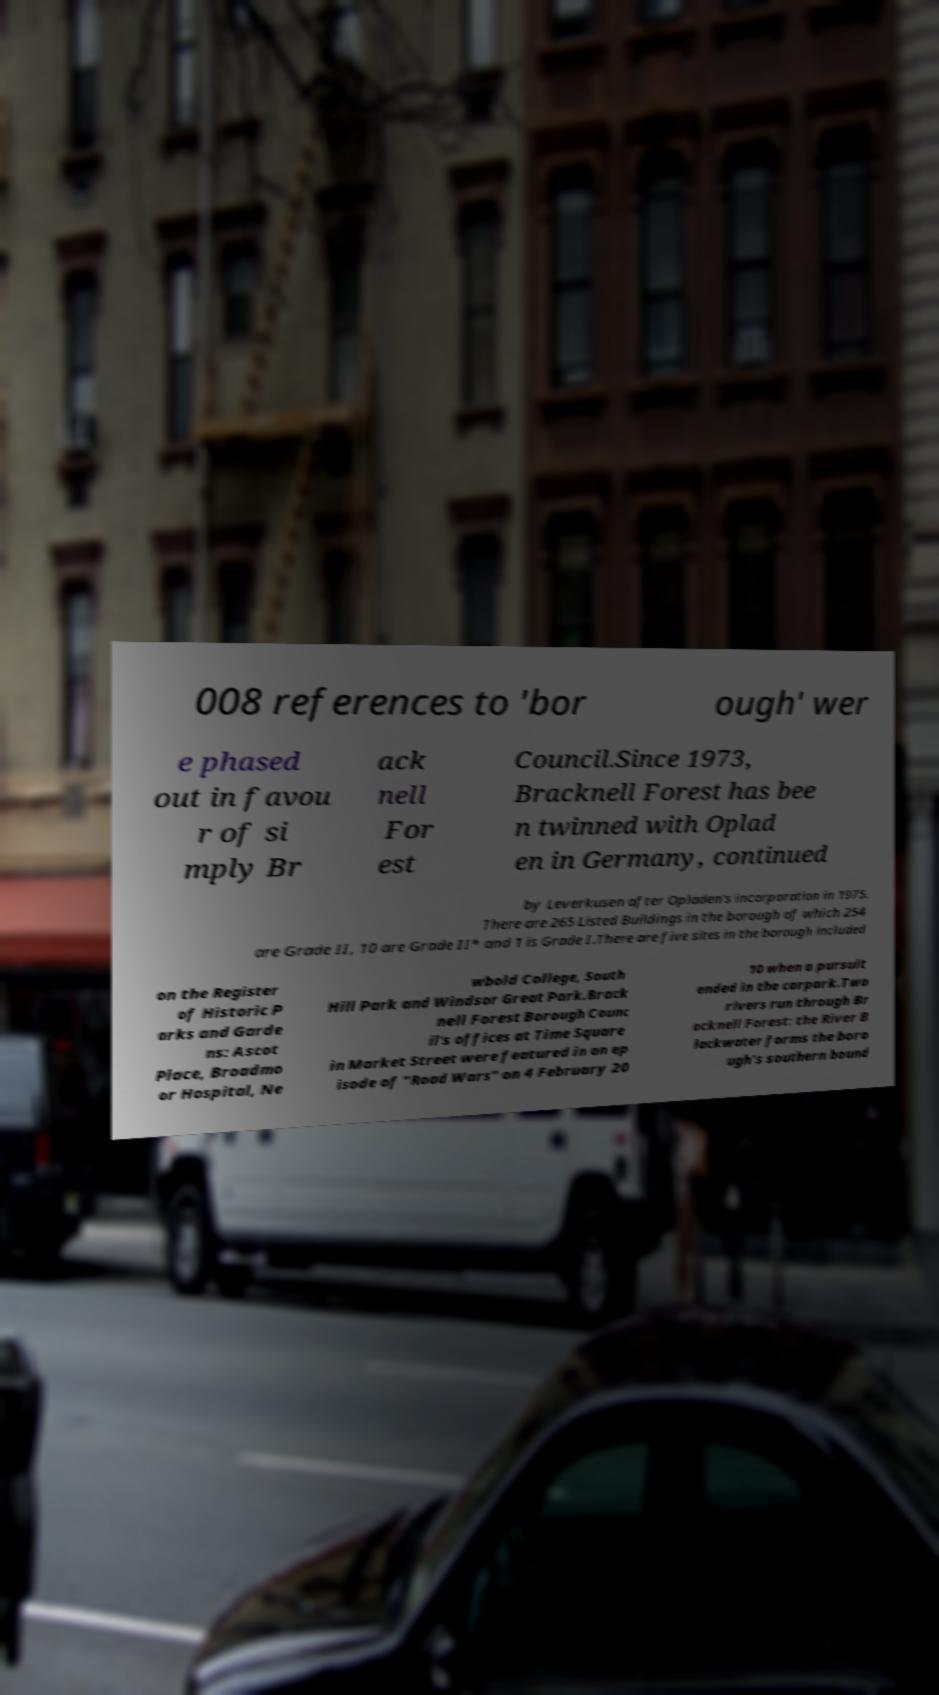Please identify and transcribe the text found in this image. 008 references to 'bor ough' wer e phased out in favou r of si mply Br ack nell For est Council.Since 1973, Bracknell Forest has bee n twinned with Oplad en in Germany, continued by Leverkusen after Opladen's incorporation in 1975. There are 265 Listed Buildings in the borough of which 254 are Grade II, 10 are Grade II* and 1 is Grade I.There are five sites in the borough included on the Register of Historic P arks and Garde ns: Ascot Place, Broadmo or Hospital, Ne wbold College, South Hill Park and Windsor Great Park.Brack nell Forest Borough Counc il's offices at Time Square in Market Street were featured in an ep isode of "Road Wars" on 4 February 20 10 when a pursuit ended in the carpark.Two rivers run through Br acknell Forest: the River B lackwater forms the boro ugh's southern bound 